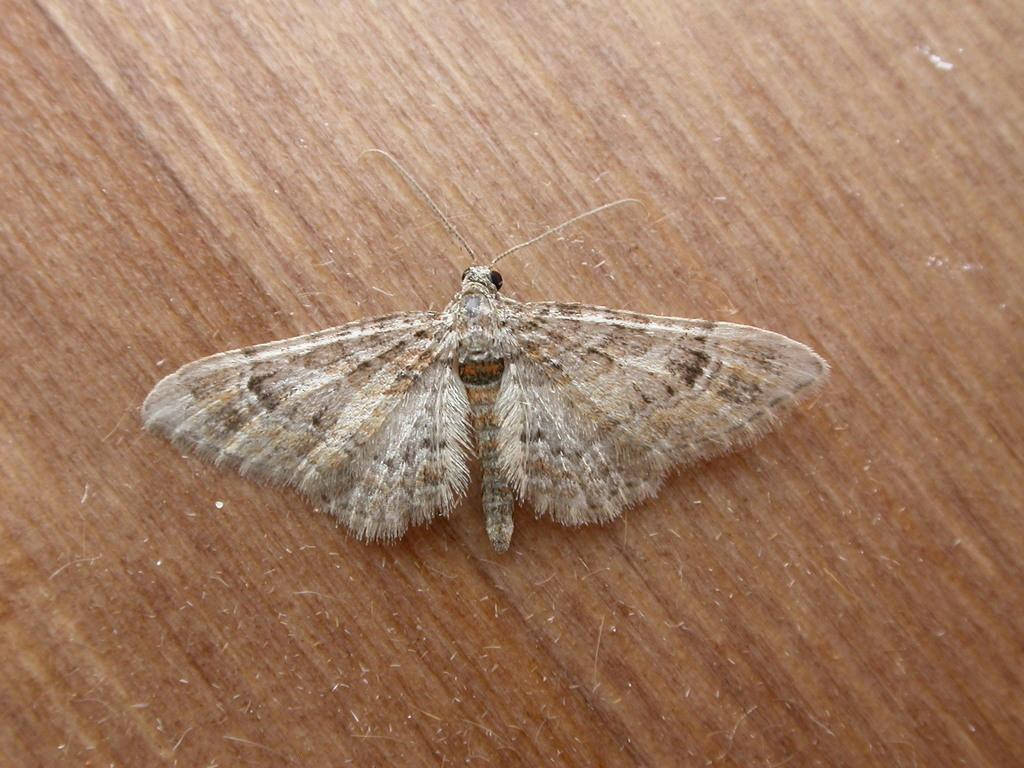What type of insect is in the image? There is a moth in the image. What is the moth placed on in the image? The moth is placed on top of a wooden object. How does the moth care for its young in the image? There is no indication in the image that the moth is caring for its young, as the image only shows the moth on a wooden object. 